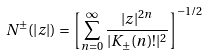<formula> <loc_0><loc_0><loc_500><loc_500>N ^ { \pm } ( | z | ) = \left [ \sum _ { n = 0 } ^ { \infty } \frac { | z | ^ { 2 n } } { | K _ { \pm } ( n ) ! | ^ { 2 } } \right ] ^ { - 1 / 2 }</formula> 